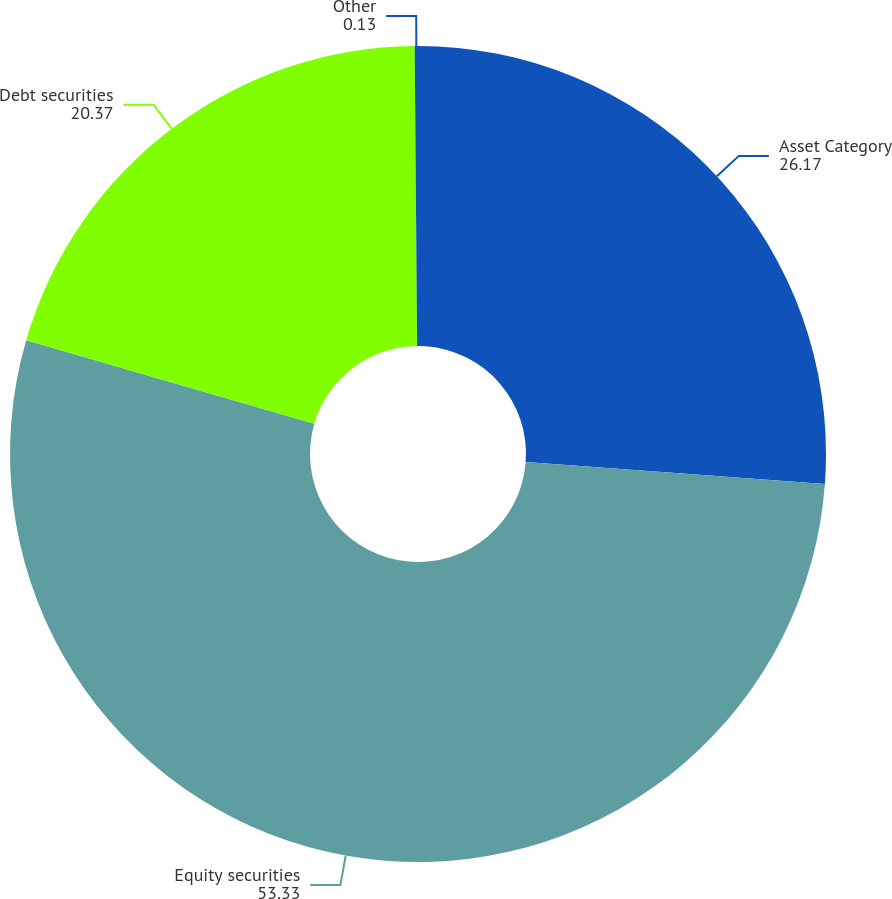Convert chart to OTSL. <chart><loc_0><loc_0><loc_500><loc_500><pie_chart><fcel>Asset Category<fcel>Equity securities<fcel>Debt securities<fcel>Other<nl><fcel>26.17%<fcel>53.33%<fcel>20.37%<fcel>0.13%<nl></chart> 